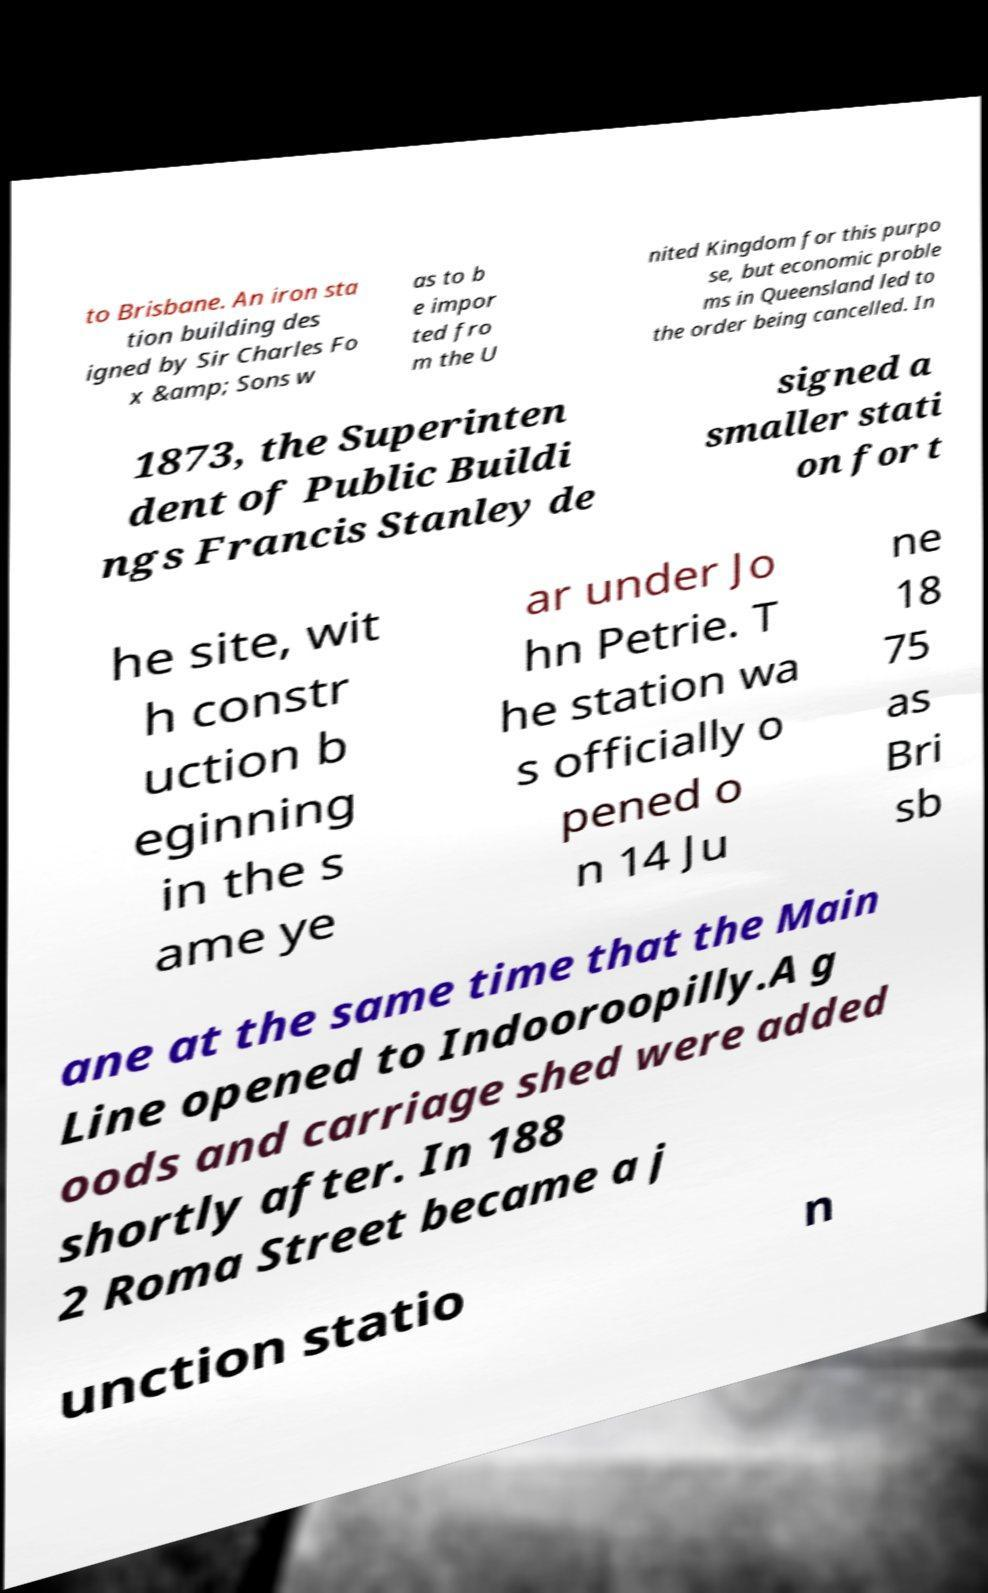Could you extract and type out the text from this image? to Brisbane. An iron sta tion building des igned by Sir Charles Fo x &amp; Sons w as to b e impor ted fro m the U nited Kingdom for this purpo se, but economic proble ms in Queensland led to the order being cancelled. In 1873, the Superinten dent of Public Buildi ngs Francis Stanley de signed a smaller stati on for t he site, wit h constr uction b eginning in the s ame ye ar under Jo hn Petrie. T he station wa s officially o pened o n 14 Ju ne 18 75 as Bri sb ane at the same time that the Main Line opened to Indooroopilly.A g oods and carriage shed were added shortly after. In 188 2 Roma Street became a j unction statio n 